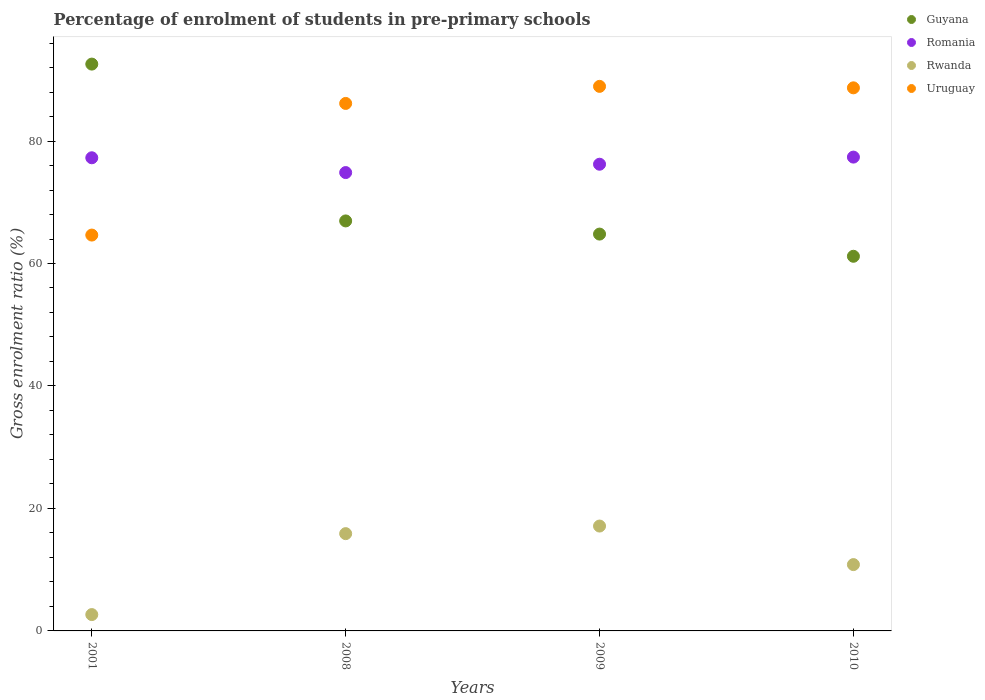How many different coloured dotlines are there?
Give a very brief answer. 4. What is the percentage of students enrolled in pre-primary schools in Guyana in 2009?
Provide a short and direct response. 64.8. Across all years, what is the maximum percentage of students enrolled in pre-primary schools in Guyana?
Give a very brief answer. 92.56. Across all years, what is the minimum percentage of students enrolled in pre-primary schools in Rwanda?
Keep it short and to the point. 2.67. In which year was the percentage of students enrolled in pre-primary schools in Romania maximum?
Offer a terse response. 2010. In which year was the percentage of students enrolled in pre-primary schools in Romania minimum?
Your answer should be compact. 2008. What is the total percentage of students enrolled in pre-primary schools in Uruguay in the graph?
Provide a succinct answer. 328.4. What is the difference between the percentage of students enrolled in pre-primary schools in Rwanda in 2009 and that in 2010?
Offer a very short reply. 6.3. What is the difference between the percentage of students enrolled in pre-primary schools in Rwanda in 2008 and the percentage of students enrolled in pre-primary schools in Romania in 2010?
Ensure brevity in your answer.  -61.49. What is the average percentage of students enrolled in pre-primary schools in Uruguay per year?
Make the answer very short. 82.1. In the year 2001, what is the difference between the percentage of students enrolled in pre-primary schools in Guyana and percentage of students enrolled in pre-primary schools in Rwanda?
Ensure brevity in your answer.  89.89. In how many years, is the percentage of students enrolled in pre-primary schools in Uruguay greater than 60 %?
Give a very brief answer. 4. What is the ratio of the percentage of students enrolled in pre-primary schools in Guyana in 2008 to that in 2009?
Your response must be concise. 1.03. Is the percentage of students enrolled in pre-primary schools in Romania in 2001 less than that in 2009?
Ensure brevity in your answer.  No. What is the difference between the highest and the second highest percentage of students enrolled in pre-primary schools in Romania?
Provide a succinct answer. 0.11. What is the difference between the highest and the lowest percentage of students enrolled in pre-primary schools in Rwanda?
Give a very brief answer. 14.46. Is it the case that in every year, the sum of the percentage of students enrolled in pre-primary schools in Uruguay and percentage of students enrolled in pre-primary schools in Rwanda  is greater than the percentage of students enrolled in pre-primary schools in Guyana?
Ensure brevity in your answer.  No. Is the percentage of students enrolled in pre-primary schools in Romania strictly less than the percentage of students enrolled in pre-primary schools in Guyana over the years?
Keep it short and to the point. No. How many dotlines are there?
Keep it short and to the point. 4. How many years are there in the graph?
Your response must be concise. 4. Where does the legend appear in the graph?
Keep it short and to the point. Top right. What is the title of the graph?
Keep it short and to the point. Percentage of enrolment of students in pre-primary schools. What is the label or title of the X-axis?
Give a very brief answer. Years. What is the Gross enrolment ratio (%) in Guyana in 2001?
Give a very brief answer. 92.56. What is the Gross enrolment ratio (%) in Romania in 2001?
Make the answer very short. 77.27. What is the Gross enrolment ratio (%) of Rwanda in 2001?
Offer a terse response. 2.67. What is the Gross enrolment ratio (%) of Uruguay in 2001?
Your answer should be compact. 64.64. What is the Gross enrolment ratio (%) of Guyana in 2008?
Ensure brevity in your answer.  66.95. What is the Gross enrolment ratio (%) in Romania in 2008?
Your answer should be very brief. 74.85. What is the Gross enrolment ratio (%) in Rwanda in 2008?
Your answer should be very brief. 15.89. What is the Gross enrolment ratio (%) in Uruguay in 2008?
Ensure brevity in your answer.  86.14. What is the Gross enrolment ratio (%) in Guyana in 2009?
Provide a short and direct response. 64.8. What is the Gross enrolment ratio (%) in Romania in 2009?
Keep it short and to the point. 76.21. What is the Gross enrolment ratio (%) of Rwanda in 2009?
Keep it short and to the point. 17.13. What is the Gross enrolment ratio (%) of Uruguay in 2009?
Your response must be concise. 88.93. What is the Gross enrolment ratio (%) of Guyana in 2010?
Your answer should be very brief. 61.18. What is the Gross enrolment ratio (%) in Romania in 2010?
Keep it short and to the point. 77.38. What is the Gross enrolment ratio (%) of Rwanda in 2010?
Provide a short and direct response. 10.83. What is the Gross enrolment ratio (%) of Uruguay in 2010?
Provide a short and direct response. 88.69. Across all years, what is the maximum Gross enrolment ratio (%) of Guyana?
Offer a terse response. 92.56. Across all years, what is the maximum Gross enrolment ratio (%) in Romania?
Your response must be concise. 77.38. Across all years, what is the maximum Gross enrolment ratio (%) in Rwanda?
Provide a succinct answer. 17.13. Across all years, what is the maximum Gross enrolment ratio (%) of Uruguay?
Provide a short and direct response. 88.93. Across all years, what is the minimum Gross enrolment ratio (%) in Guyana?
Offer a very short reply. 61.18. Across all years, what is the minimum Gross enrolment ratio (%) in Romania?
Offer a terse response. 74.85. Across all years, what is the minimum Gross enrolment ratio (%) of Rwanda?
Your answer should be very brief. 2.67. Across all years, what is the minimum Gross enrolment ratio (%) in Uruguay?
Your response must be concise. 64.64. What is the total Gross enrolment ratio (%) of Guyana in the graph?
Your response must be concise. 285.5. What is the total Gross enrolment ratio (%) of Romania in the graph?
Provide a short and direct response. 305.7. What is the total Gross enrolment ratio (%) in Rwanda in the graph?
Your response must be concise. 46.51. What is the total Gross enrolment ratio (%) in Uruguay in the graph?
Provide a short and direct response. 328.4. What is the difference between the Gross enrolment ratio (%) in Guyana in 2001 and that in 2008?
Make the answer very short. 25.61. What is the difference between the Gross enrolment ratio (%) in Romania in 2001 and that in 2008?
Offer a terse response. 2.42. What is the difference between the Gross enrolment ratio (%) of Rwanda in 2001 and that in 2008?
Make the answer very short. -13.22. What is the difference between the Gross enrolment ratio (%) in Uruguay in 2001 and that in 2008?
Make the answer very short. -21.5. What is the difference between the Gross enrolment ratio (%) of Guyana in 2001 and that in 2009?
Your answer should be very brief. 27.76. What is the difference between the Gross enrolment ratio (%) of Romania in 2001 and that in 2009?
Offer a terse response. 1.05. What is the difference between the Gross enrolment ratio (%) in Rwanda in 2001 and that in 2009?
Keep it short and to the point. -14.46. What is the difference between the Gross enrolment ratio (%) of Uruguay in 2001 and that in 2009?
Your answer should be very brief. -24.28. What is the difference between the Gross enrolment ratio (%) in Guyana in 2001 and that in 2010?
Give a very brief answer. 31.38. What is the difference between the Gross enrolment ratio (%) of Romania in 2001 and that in 2010?
Your response must be concise. -0.11. What is the difference between the Gross enrolment ratio (%) of Rwanda in 2001 and that in 2010?
Give a very brief answer. -8.16. What is the difference between the Gross enrolment ratio (%) in Uruguay in 2001 and that in 2010?
Your response must be concise. -24.04. What is the difference between the Gross enrolment ratio (%) of Guyana in 2008 and that in 2009?
Ensure brevity in your answer.  2.15. What is the difference between the Gross enrolment ratio (%) of Romania in 2008 and that in 2009?
Make the answer very short. -1.36. What is the difference between the Gross enrolment ratio (%) in Rwanda in 2008 and that in 2009?
Ensure brevity in your answer.  -1.24. What is the difference between the Gross enrolment ratio (%) of Uruguay in 2008 and that in 2009?
Make the answer very short. -2.79. What is the difference between the Gross enrolment ratio (%) in Guyana in 2008 and that in 2010?
Your answer should be compact. 5.77. What is the difference between the Gross enrolment ratio (%) of Romania in 2008 and that in 2010?
Your response must be concise. -2.53. What is the difference between the Gross enrolment ratio (%) in Rwanda in 2008 and that in 2010?
Offer a very short reply. 5.06. What is the difference between the Gross enrolment ratio (%) of Uruguay in 2008 and that in 2010?
Offer a terse response. -2.55. What is the difference between the Gross enrolment ratio (%) in Guyana in 2009 and that in 2010?
Give a very brief answer. 3.62. What is the difference between the Gross enrolment ratio (%) in Romania in 2009 and that in 2010?
Ensure brevity in your answer.  -1.16. What is the difference between the Gross enrolment ratio (%) in Rwanda in 2009 and that in 2010?
Provide a succinct answer. 6.3. What is the difference between the Gross enrolment ratio (%) in Uruguay in 2009 and that in 2010?
Your answer should be compact. 0.24. What is the difference between the Gross enrolment ratio (%) of Guyana in 2001 and the Gross enrolment ratio (%) of Romania in 2008?
Your answer should be compact. 17.71. What is the difference between the Gross enrolment ratio (%) in Guyana in 2001 and the Gross enrolment ratio (%) in Rwanda in 2008?
Keep it short and to the point. 76.68. What is the difference between the Gross enrolment ratio (%) of Guyana in 2001 and the Gross enrolment ratio (%) of Uruguay in 2008?
Your response must be concise. 6.42. What is the difference between the Gross enrolment ratio (%) in Romania in 2001 and the Gross enrolment ratio (%) in Rwanda in 2008?
Give a very brief answer. 61.38. What is the difference between the Gross enrolment ratio (%) of Romania in 2001 and the Gross enrolment ratio (%) of Uruguay in 2008?
Your response must be concise. -8.87. What is the difference between the Gross enrolment ratio (%) of Rwanda in 2001 and the Gross enrolment ratio (%) of Uruguay in 2008?
Keep it short and to the point. -83.47. What is the difference between the Gross enrolment ratio (%) of Guyana in 2001 and the Gross enrolment ratio (%) of Romania in 2009?
Offer a very short reply. 16.35. What is the difference between the Gross enrolment ratio (%) in Guyana in 2001 and the Gross enrolment ratio (%) in Rwanda in 2009?
Keep it short and to the point. 75.44. What is the difference between the Gross enrolment ratio (%) of Guyana in 2001 and the Gross enrolment ratio (%) of Uruguay in 2009?
Ensure brevity in your answer.  3.64. What is the difference between the Gross enrolment ratio (%) in Romania in 2001 and the Gross enrolment ratio (%) in Rwanda in 2009?
Offer a very short reply. 60.14. What is the difference between the Gross enrolment ratio (%) of Romania in 2001 and the Gross enrolment ratio (%) of Uruguay in 2009?
Your answer should be compact. -11.66. What is the difference between the Gross enrolment ratio (%) of Rwanda in 2001 and the Gross enrolment ratio (%) of Uruguay in 2009?
Provide a short and direct response. -86.26. What is the difference between the Gross enrolment ratio (%) in Guyana in 2001 and the Gross enrolment ratio (%) in Romania in 2010?
Offer a very short reply. 15.19. What is the difference between the Gross enrolment ratio (%) in Guyana in 2001 and the Gross enrolment ratio (%) in Rwanda in 2010?
Offer a terse response. 81.73. What is the difference between the Gross enrolment ratio (%) of Guyana in 2001 and the Gross enrolment ratio (%) of Uruguay in 2010?
Give a very brief answer. 3.88. What is the difference between the Gross enrolment ratio (%) in Romania in 2001 and the Gross enrolment ratio (%) in Rwanda in 2010?
Make the answer very short. 66.43. What is the difference between the Gross enrolment ratio (%) in Romania in 2001 and the Gross enrolment ratio (%) in Uruguay in 2010?
Your response must be concise. -11.42. What is the difference between the Gross enrolment ratio (%) of Rwanda in 2001 and the Gross enrolment ratio (%) of Uruguay in 2010?
Provide a succinct answer. -86.02. What is the difference between the Gross enrolment ratio (%) of Guyana in 2008 and the Gross enrolment ratio (%) of Romania in 2009?
Provide a succinct answer. -9.26. What is the difference between the Gross enrolment ratio (%) of Guyana in 2008 and the Gross enrolment ratio (%) of Rwanda in 2009?
Your response must be concise. 49.83. What is the difference between the Gross enrolment ratio (%) of Guyana in 2008 and the Gross enrolment ratio (%) of Uruguay in 2009?
Keep it short and to the point. -21.97. What is the difference between the Gross enrolment ratio (%) in Romania in 2008 and the Gross enrolment ratio (%) in Rwanda in 2009?
Make the answer very short. 57.72. What is the difference between the Gross enrolment ratio (%) of Romania in 2008 and the Gross enrolment ratio (%) of Uruguay in 2009?
Provide a succinct answer. -14.08. What is the difference between the Gross enrolment ratio (%) of Rwanda in 2008 and the Gross enrolment ratio (%) of Uruguay in 2009?
Make the answer very short. -73.04. What is the difference between the Gross enrolment ratio (%) of Guyana in 2008 and the Gross enrolment ratio (%) of Romania in 2010?
Give a very brief answer. -10.42. What is the difference between the Gross enrolment ratio (%) of Guyana in 2008 and the Gross enrolment ratio (%) of Rwanda in 2010?
Give a very brief answer. 56.12. What is the difference between the Gross enrolment ratio (%) in Guyana in 2008 and the Gross enrolment ratio (%) in Uruguay in 2010?
Your response must be concise. -21.73. What is the difference between the Gross enrolment ratio (%) of Romania in 2008 and the Gross enrolment ratio (%) of Rwanda in 2010?
Offer a terse response. 64.02. What is the difference between the Gross enrolment ratio (%) in Romania in 2008 and the Gross enrolment ratio (%) in Uruguay in 2010?
Make the answer very short. -13.84. What is the difference between the Gross enrolment ratio (%) in Rwanda in 2008 and the Gross enrolment ratio (%) in Uruguay in 2010?
Give a very brief answer. -72.8. What is the difference between the Gross enrolment ratio (%) in Guyana in 2009 and the Gross enrolment ratio (%) in Romania in 2010?
Keep it short and to the point. -12.57. What is the difference between the Gross enrolment ratio (%) of Guyana in 2009 and the Gross enrolment ratio (%) of Rwanda in 2010?
Keep it short and to the point. 53.97. What is the difference between the Gross enrolment ratio (%) in Guyana in 2009 and the Gross enrolment ratio (%) in Uruguay in 2010?
Offer a very short reply. -23.88. What is the difference between the Gross enrolment ratio (%) in Romania in 2009 and the Gross enrolment ratio (%) in Rwanda in 2010?
Give a very brief answer. 65.38. What is the difference between the Gross enrolment ratio (%) of Romania in 2009 and the Gross enrolment ratio (%) of Uruguay in 2010?
Offer a very short reply. -12.47. What is the difference between the Gross enrolment ratio (%) in Rwanda in 2009 and the Gross enrolment ratio (%) in Uruguay in 2010?
Provide a succinct answer. -71.56. What is the average Gross enrolment ratio (%) in Guyana per year?
Your response must be concise. 71.38. What is the average Gross enrolment ratio (%) of Romania per year?
Offer a very short reply. 76.43. What is the average Gross enrolment ratio (%) of Rwanda per year?
Offer a very short reply. 11.63. What is the average Gross enrolment ratio (%) of Uruguay per year?
Keep it short and to the point. 82.1. In the year 2001, what is the difference between the Gross enrolment ratio (%) of Guyana and Gross enrolment ratio (%) of Romania?
Give a very brief answer. 15.3. In the year 2001, what is the difference between the Gross enrolment ratio (%) of Guyana and Gross enrolment ratio (%) of Rwanda?
Offer a terse response. 89.89. In the year 2001, what is the difference between the Gross enrolment ratio (%) in Guyana and Gross enrolment ratio (%) in Uruguay?
Ensure brevity in your answer.  27.92. In the year 2001, what is the difference between the Gross enrolment ratio (%) of Romania and Gross enrolment ratio (%) of Rwanda?
Provide a succinct answer. 74.6. In the year 2001, what is the difference between the Gross enrolment ratio (%) of Romania and Gross enrolment ratio (%) of Uruguay?
Offer a very short reply. 12.62. In the year 2001, what is the difference between the Gross enrolment ratio (%) of Rwanda and Gross enrolment ratio (%) of Uruguay?
Your response must be concise. -61.98. In the year 2008, what is the difference between the Gross enrolment ratio (%) in Guyana and Gross enrolment ratio (%) in Romania?
Offer a very short reply. -7.9. In the year 2008, what is the difference between the Gross enrolment ratio (%) in Guyana and Gross enrolment ratio (%) in Rwanda?
Your answer should be very brief. 51.07. In the year 2008, what is the difference between the Gross enrolment ratio (%) of Guyana and Gross enrolment ratio (%) of Uruguay?
Keep it short and to the point. -19.19. In the year 2008, what is the difference between the Gross enrolment ratio (%) of Romania and Gross enrolment ratio (%) of Rwanda?
Offer a terse response. 58.96. In the year 2008, what is the difference between the Gross enrolment ratio (%) in Romania and Gross enrolment ratio (%) in Uruguay?
Ensure brevity in your answer.  -11.29. In the year 2008, what is the difference between the Gross enrolment ratio (%) in Rwanda and Gross enrolment ratio (%) in Uruguay?
Make the answer very short. -70.25. In the year 2009, what is the difference between the Gross enrolment ratio (%) in Guyana and Gross enrolment ratio (%) in Romania?
Ensure brevity in your answer.  -11.41. In the year 2009, what is the difference between the Gross enrolment ratio (%) of Guyana and Gross enrolment ratio (%) of Rwanda?
Give a very brief answer. 47.68. In the year 2009, what is the difference between the Gross enrolment ratio (%) of Guyana and Gross enrolment ratio (%) of Uruguay?
Offer a very short reply. -24.12. In the year 2009, what is the difference between the Gross enrolment ratio (%) of Romania and Gross enrolment ratio (%) of Rwanda?
Your answer should be compact. 59.09. In the year 2009, what is the difference between the Gross enrolment ratio (%) in Romania and Gross enrolment ratio (%) in Uruguay?
Make the answer very short. -12.71. In the year 2009, what is the difference between the Gross enrolment ratio (%) in Rwanda and Gross enrolment ratio (%) in Uruguay?
Your answer should be very brief. -71.8. In the year 2010, what is the difference between the Gross enrolment ratio (%) in Guyana and Gross enrolment ratio (%) in Romania?
Provide a short and direct response. -16.2. In the year 2010, what is the difference between the Gross enrolment ratio (%) in Guyana and Gross enrolment ratio (%) in Rwanda?
Offer a terse response. 50.35. In the year 2010, what is the difference between the Gross enrolment ratio (%) of Guyana and Gross enrolment ratio (%) of Uruguay?
Offer a very short reply. -27.51. In the year 2010, what is the difference between the Gross enrolment ratio (%) in Romania and Gross enrolment ratio (%) in Rwanda?
Offer a very short reply. 66.55. In the year 2010, what is the difference between the Gross enrolment ratio (%) in Romania and Gross enrolment ratio (%) in Uruguay?
Make the answer very short. -11.31. In the year 2010, what is the difference between the Gross enrolment ratio (%) in Rwanda and Gross enrolment ratio (%) in Uruguay?
Offer a very short reply. -77.86. What is the ratio of the Gross enrolment ratio (%) in Guyana in 2001 to that in 2008?
Provide a short and direct response. 1.38. What is the ratio of the Gross enrolment ratio (%) in Romania in 2001 to that in 2008?
Keep it short and to the point. 1.03. What is the ratio of the Gross enrolment ratio (%) of Rwanda in 2001 to that in 2008?
Your answer should be compact. 0.17. What is the ratio of the Gross enrolment ratio (%) of Uruguay in 2001 to that in 2008?
Make the answer very short. 0.75. What is the ratio of the Gross enrolment ratio (%) in Guyana in 2001 to that in 2009?
Keep it short and to the point. 1.43. What is the ratio of the Gross enrolment ratio (%) in Romania in 2001 to that in 2009?
Give a very brief answer. 1.01. What is the ratio of the Gross enrolment ratio (%) of Rwanda in 2001 to that in 2009?
Provide a short and direct response. 0.16. What is the ratio of the Gross enrolment ratio (%) in Uruguay in 2001 to that in 2009?
Your response must be concise. 0.73. What is the ratio of the Gross enrolment ratio (%) in Guyana in 2001 to that in 2010?
Keep it short and to the point. 1.51. What is the ratio of the Gross enrolment ratio (%) of Romania in 2001 to that in 2010?
Give a very brief answer. 1. What is the ratio of the Gross enrolment ratio (%) in Rwanda in 2001 to that in 2010?
Give a very brief answer. 0.25. What is the ratio of the Gross enrolment ratio (%) of Uruguay in 2001 to that in 2010?
Your answer should be very brief. 0.73. What is the ratio of the Gross enrolment ratio (%) of Guyana in 2008 to that in 2009?
Your answer should be very brief. 1.03. What is the ratio of the Gross enrolment ratio (%) in Romania in 2008 to that in 2009?
Offer a terse response. 0.98. What is the ratio of the Gross enrolment ratio (%) in Rwanda in 2008 to that in 2009?
Give a very brief answer. 0.93. What is the ratio of the Gross enrolment ratio (%) of Uruguay in 2008 to that in 2009?
Offer a very short reply. 0.97. What is the ratio of the Gross enrolment ratio (%) of Guyana in 2008 to that in 2010?
Keep it short and to the point. 1.09. What is the ratio of the Gross enrolment ratio (%) in Romania in 2008 to that in 2010?
Keep it short and to the point. 0.97. What is the ratio of the Gross enrolment ratio (%) in Rwanda in 2008 to that in 2010?
Make the answer very short. 1.47. What is the ratio of the Gross enrolment ratio (%) of Uruguay in 2008 to that in 2010?
Ensure brevity in your answer.  0.97. What is the ratio of the Gross enrolment ratio (%) of Guyana in 2009 to that in 2010?
Offer a very short reply. 1.06. What is the ratio of the Gross enrolment ratio (%) of Romania in 2009 to that in 2010?
Offer a very short reply. 0.98. What is the ratio of the Gross enrolment ratio (%) in Rwanda in 2009 to that in 2010?
Provide a succinct answer. 1.58. What is the ratio of the Gross enrolment ratio (%) of Uruguay in 2009 to that in 2010?
Ensure brevity in your answer.  1. What is the difference between the highest and the second highest Gross enrolment ratio (%) of Guyana?
Give a very brief answer. 25.61. What is the difference between the highest and the second highest Gross enrolment ratio (%) in Romania?
Provide a short and direct response. 0.11. What is the difference between the highest and the second highest Gross enrolment ratio (%) in Rwanda?
Your answer should be very brief. 1.24. What is the difference between the highest and the second highest Gross enrolment ratio (%) of Uruguay?
Make the answer very short. 0.24. What is the difference between the highest and the lowest Gross enrolment ratio (%) of Guyana?
Provide a succinct answer. 31.38. What is the difference between the highest and the lowest Gross enrolment ratio (%) in Romania?
Make the answer very short. 2.53. What is the difference between the highest and the lowest Gross enrolment ratio (%) in Rwanda?
Provide a short and direct response. 14.46. What is the difference between the highest and the lowest Gross enrolment ratio (%) in Uruguay?
Provide a succinct answer. 24.28. 